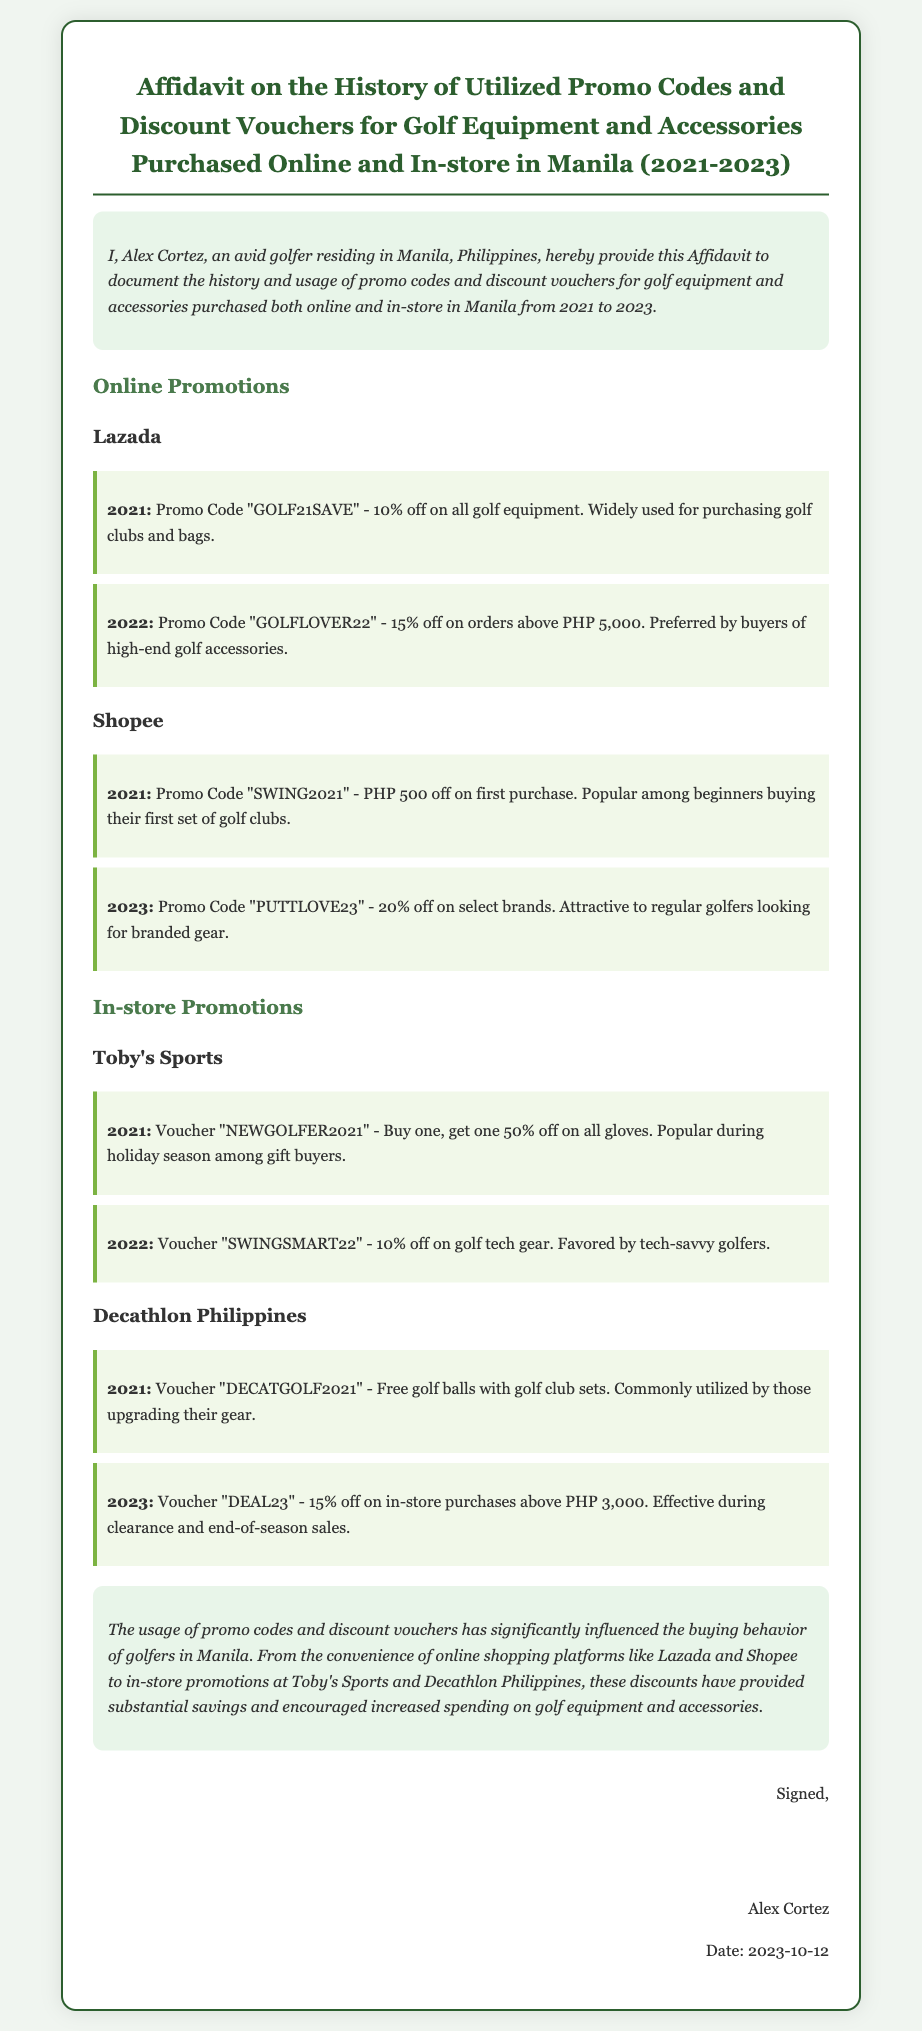What is the name of the person providing the affidavit? The affidavit is provided by Alex Cortez, as stated in the introductory section.
Answer: Alex Cortez What year was the promo code "GOLFLOVER22" used? The document mentions the promo code "GOLFLOVER22" was used in 2022.
Answer: 2022 What discount does the voucher "NEWGOLFER2021" offer? The voucher "NEWGOLFER2021" offers buy one, get one 50% off on all gloves.
Answer: buy one, get one 50% off Which online store has the promo code "PUTTLOVE23"? The promo code "PUTTLOVE23" is associated with Shopee, as indicated in the online promotions section.
Answer: Shopee How much off does the promo code "SWING2021" provide? The promo code "SWING2021" offers PHP 500 off on the first purchase.
Answer: PHP 500 What is the main conclusion regarding promo codes and discount vouchers? The conclusion discusses the influence of promo codes and discount vouchers on buying behavior, emphasizing their importance for savings and spending.
Answer: Influence on buying behavior What is the year mentioned for the voucher "DEAL23"? The voucher "DEAL23" is mentioned for the year 2023 in the document.
Answer: 2023 Who signed the affidavit? The affidavit is signed by Alex Cortez, as noted in the signature section.
Answer: Alex Cortez What type of document is this? The document is categorized as an affidavit based on its title and introductory statement.
Answer: Affidavit 